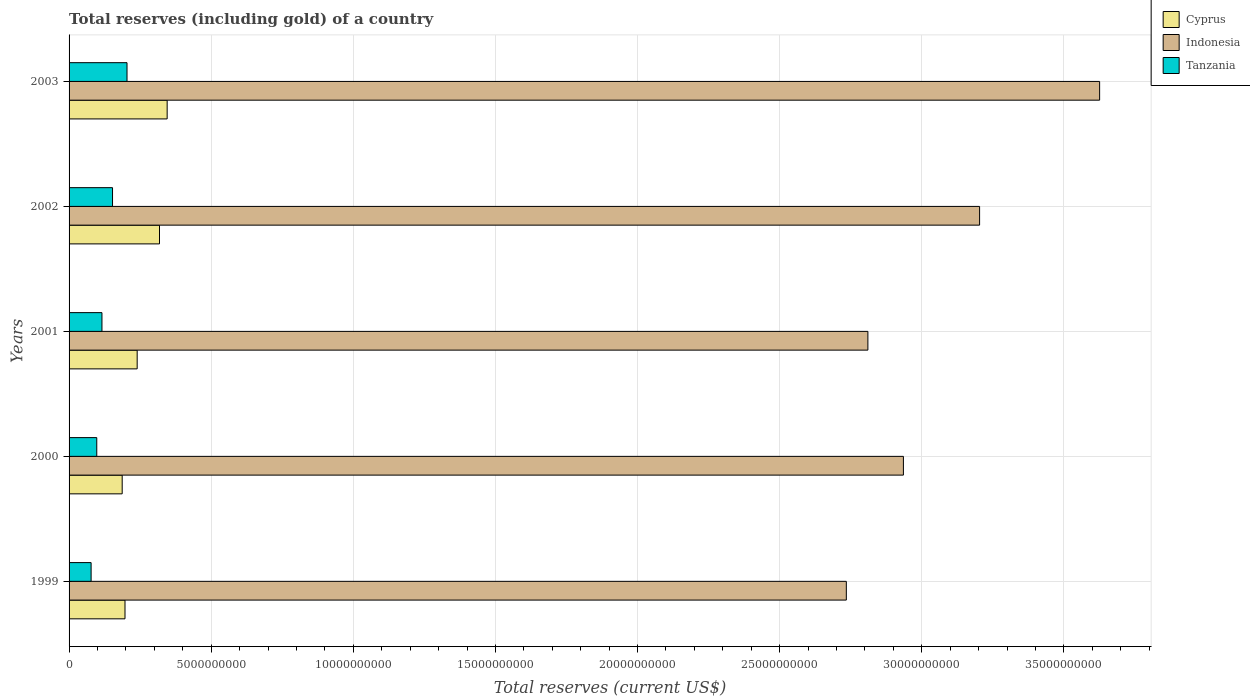Are the number of bars per tick equal to the number of legend labels?
Provide a succinct answer. Yes. Are the number of bars on each tick of the Y-axis equal?
Your answer should be compact. Yes. How many bars are there on the 2nd tick from the top?
Your answer should be compact. 3. How many bars are there on the 2nd tick from the bottom?
Ensure brevity in your answer.  3. What is the label of the 5th group of bars from the top?
Your response must be concise. 1999. In how many cases, is the number of bars for a given year not equal to the number of legend labels?
Offer a terse response. 0. What is the total reserves (including gold) in Cyprus in 2001?
Make the answer very short. 2.40e+09. Across all years, what is the maximum total reserves (including gold) in Indonesia?
Your response must be concise. 3.63e+1. Across all years, what is the minimum total reserves (including gold) in Tanzania?
Your response must be concise. 7.75e+08. In which year was the total reserves (including gold) in Cyprus maximum?
Keep it short and to the point. 2003. In which year was the total reserves (including gold) in Indonesia minimum?
Ensure brevity in your answer.  1999. What is the total total reserves (including gold) in Tanzania in the graph?
Offer a very short reply. 6.47e+09. What is the difference between the total reserves (including gold) in Tanzania in 2000 and that in 2002?
Your response must be concise. -5.55e+08. What is the difference between the total reserves (including gold) in Tanzania in 1999 and the total reserves (including gold) in Cyprus in 2002?
Give a very brief answer. -2.41e+09. What is the average total reserves (including gold) in Cyprus per year?
Offer a very short reply. 2.57e+09. In the year 2002, what is the difference between the total reserves (including gold) in Indonesia and total reserves (including gold) in Tanzania?
Provide a succinct answer. 3.05e+1. What is the ratio of the total reserves (including gold) in Tanzania in 2000 to that in 2002?
Your answer should be compact. 0.64. Is the difference between the total reserves (including gold) in Indonesia in 2001 and 2003 greater than the difference between the total reserves (including gold) in Tanzania in 2001 and 2003?
Provide a succinct answer. No. What is the difference between the highest and the second highest total reserves (including gold) in Indonesia?
Your answer should be compact. 4.22e+09. What is the difference between the highest and the lowest total reserves (including gold) in Tanzania?
Give a very brief answer. 1.26e+09. In how many years, is the total reserves (including gold) in Cyprus greater than the average total reserves (including gold) in Cyprus taken over all years?
Give a very brief answer. 2. What does the 2nd bar from the top in 2003 represents?
Your response must be concise. Indonesia. What does the 1st bar from the bottom in 2000 represents?
Make the answer very short. Cyprus. How many years are there in the graph?
Provide a short and direct response. 5. What is the difference between two consecutive major ticks on the X-axis?
Your answer should be very brief. 5.00e+09. Are the values on the major ticks of X-axis written in scientific E-notation?
Ensure brevity in your answer.  No. Does the graph contain grids?
Give a very brief answer. Yes. Where does the legend appear in the graph?
Your answer should be very brief. Top right. What is the title of the graph?
Provide a succinct answer. Total reserves (including gold) of a country. What is the label or title of the X-axis?
Ensure brevity in your answer.  Total reserves (current US$). What is the label or title of the Y-axis?
Your response must be concise. Years. What is the Total reserves (current US$) in Cyprus in 1999?
Offer a terse response. 1.97e+09. What is the Total reserves (current US$) of Indonesia in 1999?
Give a very brief answer. 2.73e+1. What is the Total reserves (current US$) in Tanzania in 1999?
Your answer should be compact. 7.75e+08. What is the Total reserves (current US$) in Cyprus in 2000?
Your answer should be very brief. 1.87e+09. What is the Total reserves (current US$) in Indonesia in 2000?
Your response must be concise. 2.94e+1. What is the Total reserves (current US$) in Tanzania in 2000?
Provide a short and direct response. 9.74e+08. What is the Total reserves (current US$) of Cyprus in 2001?
Offer a terse response. 2.40e+09. What is the Total reserves (current US$) in Indonesia in 2001?
Keep it short and to the point. 2.81e+1. What is the Total reserves (current US$) of Tanzania in 2001?
Your response must be concise. 1.16e+09. What is the Total reserves (current US$) in Cyprus in 2002?
Your response must be concise. 3.18e+09. What is the Total reserves (current US$) of Indonesia in 2002?
Offer a terse response. 3.20e+1. What is the Total reserves (current US$) in Tanzania in 2002?
Make the answer very short. 1.53e+09. What is the Total reserves (current US$) in Cyprus in 2003?
Offer a terse response. 3.45e+09. What is the Total reserves (current US$) of Indonesia in 2003?
Give a very brief answer. 3.63e+1. What is the Total reserves (current US$) of Tanzania in 2003?
Offer a terse response. 2.04e+09. Across all years, what is the maximum Total reserves (current US$) in Cyprus?
Your answer should be very brief. 3.45e+09. Across all years, what is the maximum Total reserves (current US$) in Indonesia?
Provide a short and direct response. 3.63e+1. Across all years, what is the maximum Total reserves (current US$) in Tanzania?
Keep it short and to the point. 2.04e+09. Across all years, what is the minimum Total reserves (current US$) in Cyprus?
Make the answer very short. 1.87e+09. Across all years, what is the minimum Total reserves (current US$) of Indonesia?
Your answer should be very brief. 2.73e+1. Across all years, what is the minimum Total reserves (current US$) of Tanzania?
Provide a short and direct response. 7.75e+08. What is the total Total reserves (current US$) of Cyprus in the graph?
Your answer should be compact. 1.29e+1. What is the total Total reserves (current US$) of Indonesia in the graph?
Give a very brief answer. 1.53e+11. What is the total Total reserves (current US$) of Tanzania in the graph?
Your response must be concise. 6.47e+09. What is the difference between the Total reserves (current US$) of Cyprus in 1999 and that in 2000?
Give a very brief answer. 9.89e+07. What is the difference between the Total reserves (current US$) of Indonesia in 1999 and that in 2000?
Offer a very short reply. -2.01e+09. What is the difference between the Total reserves (current US$) in Tanzania in 1999 and that in 2000?
Make the answer very short. -1.99e+08. What is the difference between the Total reserves (current US$) in Cyprus in 1999 and that in 2001?
Offer a terse response. -4.29e+08. What is the difference between the Total reserves (current US$) in Indonesia in 1999 and that in 2001?
Offer a terse response. -7.59e+08. What is the difference between the Total reserves (current US$) of Tanzania in 1999 and that in 2001?
Keep it short and to the point. -3.81e+08. What is the difference between the Total reserves (current US$) of Cyprus in 1999 and that in 2002?
Ensure brevity in your answer.  -1.21e+09. What is the difference between the Total reserves (current US$) of Indonesia in 1999 and that in 2002?
Your answer should be very brief. -4.69e+09. What is the difference between the Total reserves (current US$) in Tanzania in 1999 and that in 2002?
Your response must be concise. -7.53e+08. What is the difference between the Total reserves (current US$) in Cyprus in 1999 and that in 2003?
Offer a terse response. -1.48e+09. What is the difference between the Total reserves (current US$) in Indonesia in 1999 and that in 2003?
Provide a succinct answer. -8.91e+09. What is the difference between the Total reserves (current US$) in Tanzania in 1999 and that in 2003?
Make the answer very short. -1.26e+09. What is the difference between the Total reserves (current US$) in Cyprus in 2000 and that in 2001?
Offer a terse response. -5.28e+08. What is the difference between the Total reserves (current US$) of Indonesia in 2000 and that in 2001?
Offer a terse response. 1.25e+09. What is the difference between the Total reserves (current US$) of Tanzania in 2000 and that in 2001?
Your answer should be very brief. -1.82e+08. What is the difference between the Total reserves (current US$) of Cyprus in 2000 and that in 2002?
Your answer should be compact. -1.31e+09. What is the difference between the Total reserves (current US$) in Indonesia in 2000 and that in 2002?
Make the answer very short. -2.68e+09. What is the difference between the Total reserves (current US$) of Tanzania in 2000 and that in 2002?
Keep it short and to the point. -5.55e+08. What is the difference between the Total reserves (current US$) in Cyprus in 2000 and that in 2003?
Offer a very short reply. -1.58e+09. What is the difference between the Total reserves (current US$) in Indonesia in 2000 and that in 2003?
Make the answer very short. -6.90e+09. What is the difference between the Total reserves (current US$) of Tanzania in 2000 and that in 2003?
Provide a succinct answer. -1.06e+09. What is the difference between the Total reserves (current US$) of Cyprus in 2001 and that in 2002?
Your answer should be compact. -7.85e+08. What is the difference between the Total reserves (current US$) in Indonesia in 2001 and that in 2002?
Ensure brevity in your answer.  -3.93e+09. What is the difference between the Total reserves (current US$) of Tanzania in 2001 and that in 2002?
Offer a terse response. -3.72e+08. What is the difference between the Total reserves (current US$) of Cyprus in 2001 and that in 2003?
Keep it short and to the point. -1.05e+09. What is the difference between the Total reserves (current US$) in Indonesia in 2001 and that in 2003?
Keep it short and to the point. -8.15e+09. What is the difference between the Total reserves (current US$) of Tanzania in 2001 and that in 2003?
Provide a short and direct response. -8.82e+08. What is the difference between the Total reserves (current US$) in Cyprus in 2002 and that in 2003?
Provide a short and direct response. -2.70e+08. What is the difference between the Total reserves (current US$) of Indonesia in 2002 and that in 2003?
Offer a terse response. -4.22e+09. What is the difference between the Total reserves (current US$) of Tanzania in 2002 and that in 2003?
Your answer should be very brief. -5.10e+08. What is the difference between the Total reserves (current US$) in Cyprus in 1999 and the Total reserves (current US$) in Indonesia in 2000?
Give a very brief answer. -2.74e+1. What is the difference between the Total reserves (current US$) in Cyprus in 1999 and the Total reserves (current US$) in Tanzania in 2000?
Keep it short and to the point. 9.93e+08. What is the difference between the Total reserves (current US$) of Indonesia in 1999 and the Total reserves (current US$) of Tanzania in 2000?
Keep it short and to the point. 2.64e+1. What is the difference between the Total reserves (current US$) of Cyprus in 1999 and the Total reserves (current US$) of Indonesia in 2001?
Offer a terse response. -2.61e+1. What is the difference between the Total reserves (current US$) of Cyprus in 1999 and the Total reserves (current US$) of Tanzania in 2001?
Your response must be concise. 8.11e+08. What is the difference between the Total reserves (current US$) in Indonesia in 1999 and the Total reserves (current US$) in Tanzania in 2001?
Make the answer very short. 2.62e+1. What is the difference between the Total reserves (current US$) of Cyprus in 1999 and the Total reserves (current US$) of Indonesia in 2002?
Your answer should be very brief. -3.01e+1. What is the difference between the Total reserves (current US$) in Cyprus in 1999 and the Total reserves (current US$) in Tanzania in 2002?
Offer a terse response. 4.39e+08. What is the difference between the Total reserves (current US$) of Indonesia in 1999 and the Total reserves (current US$) of Tanzania in 2002?
Your response must be concise. 2.58e+1. What is the difference between the Total reserves (current US$) in Cyprus in 1999 and the Total reserves (current US$) in Indonesia in 2003?
Ensure brevity in your answer.  -3.43e+1. What is the difference between the Total reserves (current US$) in Cyprus in 1999 and the Total reserves (current US$) in Tanzania in 2003?
Provide a short and direct response. -7.10e+07. What is the difference between the Total reserves (current US$) in Indonesia in 1999 and the Total reserves (current US$) in Tanzania in 2003?
Give a very brief answer. 2.53e+1. What is the difference between the Total reserves (current US$) in Cyprus in 2000 and the Total reserves (current US$) in Indonesia in 2001?
Ensure brevity in your answer.  -2.62e+1. What is the difference between the Total reserves (current US$) in Cyprus in 2000 and the Total reserves (current US$) in Tanzania in 2001?
Offer a terse response. 7.12e+08. What is the difference between the Total reserves (current US$) of Indonesia in 2000 and the Total reserves (current US$) of Tanzania in 2001?
Give a very brief answer. 2.82e+1. What is the difference between the Total reserves (current US$) in Cyprus in 2000 and the Total reserves (current US$) in Indonesia in 2002?
Your response must be concise. -3.02e+1. What is the difference between the Total reserves (current US$) in Cyprus in 2000 and the Total reserves (current US$) in Tanzania in 2002?
Your response must be concise. 3.40e+08. What is the difference between the Total reserves (current US$) of Indonesia in 2000 and the Total reserves (current US$) of Tanzania in 2002?
Offer a terse response. 2.78e+1. What is the difference between the Total reserves (current US$) in Cyprus in 2000 and the Total reserves (current US$) in Indonesia in 2003?
Your response must be concise. -3.44e+1. What is the difference between the Total reserves (current US$) of Cyprus in 2000 and the Total reserves (current US$) of Tanzania in 2003?
Make the answer very short. -1.70e+08. What is the difference between the Total reserves (current US$) in Indonesia in 2000 and the Total reserves (current US$) in Tanzania in 2003?
Ensure brevity in your answer.  2.73e+1. What is the difference between the Total reserves (current US$) of Cyprus in 2001 and the Total reserves (current US$) of Indonesia in 2002?
Provide a succinct answer. -2.96e+1. What is the difference between the Total reserves (current US$) in Cyprus in 2001 and the Total reserves (current US$) in Tanzania in 2002?
Give a very brief answer. 8.67e+08. What is the difference between the Total reserves (current US$) in Indonesia in 2001 and the Total reserves (current US$) in Tanzania in 2002?
Offer a terse response. 2.66e+1. What is the difference between the Total reserves (current US$) of Cyprus in 2001 and the Total reserves (current US$) of Indonesia in 2003?
Your response must be concise. -3.39e+1. What is the difference between the Total reserves (current US$) in Cyprus in 2001 and the Total reserves (current US$) in Tanzania in 2003?
Ensure brevity in your answer.  3.58e+08. What is the difference between the Total reserves (current US$) in Indonesia in 2001 and the Total reserves (current US$) in Tanzania in 2003?
Ensure brevity in your answer.  2.61e+1. What is the difference between the Total reserves (current US$) in Cyprus in 2002 and the Total reserves (current US$) in Indonesia in 2003?
Give a very brief answer. -3.31e+1. What is the difference between the Total reserves (current US$) of Cyprus in 2002 and the Total reserves (current US$) of Tanzania in 2003?
Your answer should be compact. 1.14e+09. What is the difference between the Total reserves (current US$) in Indonesia in 2002 and the Total reserves (current US$) in Tanzania in 2003?
Ensure brevity in your answer.  3.00e+1. What is the average Total reserves (current US$) in Cyprus per year?
Offer a terse response. 2.57e+09. What is the average Total reserves (current US$) of Indonesia per year?
Ensure brevity in your answer.  3.06e+1. What is the average Total reserves (current US$) of Tanzania per year?
Your answer should be compact. 1.29e+09. In the year 1999, what is the difference between the Total reserves (current US$) of Cyprus and Total reserves (current US$) of Indonesia?
Offer a terse response. -2.54e+1. In the year 1999, what is the difference between the Total reserves (current US$) of Cyprus and Total reserves (current US$) of Tanzania?
Offer a terse response. 1.19e+09. In the year 1999, what is the difference between the Total reserves (current US$) in Indonesia and Total reserves (current US$) in Tanzania?
Offer a very short reply. 2.66e+1. In the year 2000, what is the difference between the Total reserves (current US$) in Cyprus and Total reserves (current US$) in Indonesia?
Offer a very short reply. -2.75e+1. In the year 2000, what is the difference between the Total reserves (current US$) of Cyprus and Total reserves (current US$) of Tanzania?
Offer a terse response. 8.94e+08. In the year 2000, what is the difference between the Total reserves (current US$) in Indonesia and Total reserves (current US$) in Tanzania?
Your answer should be compact. 2.84e+1. In the year 2001, what is the difference between the Total reserves (current US$) of Cyprus and Total reserves (current US$) of Indonesia?
Your response must be concise. -2.57e+1. In the year 2001, what is the difference between the Total reserves (current US$) of Cyprus and Total reserves (current US$) of Tanzania?
Offer a very short reply. 1.24e+09. In the year 2001, what is the difference between the Total reserves (current US$) in Indonesia and Total reserves (current US$) in Tanzania?
Give a very brief answer. 2.69e+1. In the year 2002, what is the difference between the Total reserves (current US$) of Cyprus and Total reserves (current US$) of Indonesia?
Offer a very short reply. -2.89e+1. In the year 2002, what is the difference between the Total reserves (current US$) in Cyprus and Total reserves (current US$) in Tanzania?
Your answer should be very brief. 1.65e+09. In the year 2002, what is the difference between the Total reserves (current US$) in Indonesia and Total reserves (current US$) in Tanzania?
Your answer should be very brief. 3.05e+1. In the year 2003, what is the difference between the Total reserves (current US$) in Cyprus and Total reserves (current US$) in Indonesia?
Your response must be concise. -3.28e+1. In the year 2003, what is the difference between the Total reserves (current US$) in Cyprus and Total reserves (current US$) in Tanzania?
Your answer should be very brief. 1.41e+09. In the year 2003, what is the difference between the Total reserves (current US$) in Indonesia and Total reserves (current US$) in Tanzania?
Offer a very short reply. 3.42e+1. What is the ratio of the Total reserves (current US$) in Cyprus in 1999 to that in 2000?
Give a very brief answer. 1.05. What is the ratio of the Total reserves (current US$) of Indonesia in 1999 to that in 2000?
Provide a succinct answer. 0.93. What is the ratio of the Total reserves (current US$) of Tanzania in 1999 to that in 2000?
Keep it short and to the point. 0.8. What is the ratio of the Total reserves (current US$) of Cyprus in 1999 to that in 2001?
Provide a succinct answer. 0.82. What is the ratio of the Total reserves (current US$) in Indonesia in 1999 to that in 2001?
Your answer should be very brief. 0.97. What is the ratio of the Total reserves (current US$) of Tanzania in 1999 to that in 2001?
Keep it short and to the point. 0.67. What is the ratio of the Total reserves (current US$) in Cyprus in 1999 to that in 2002?
Your answer should be compact. 0.62. What is the ratio of the Total reserves (current US$) in Indonesia in 1999 to that in 2002?
Offer a very short reply. 0.85. What is the ratio of the Total reserves (current US$) of Tanzania in 1999 to that in 2002?
Your answer should be compact. 0.51. What is the ratio of the Total reserves (current US$) in Cyprus in 1999 to that in 2003?
Your response must be concise. 0.57. What is the ratio of the Total reserves (current US$) of Indonesia in 1999 to that in 2003?
Keep it short and to the point. 0.75. What is the ratio of the Total reserves (current US$) in Tanzania in 1999 to that in 2003?
Provide a succinct answer. 0.38. What is the ratio of the Total reserves (current US$) of Cyprus in 2000 to that in 2001?
Give a very brief answer. 0.78. What is the ratio of the Total reserves (current US$) of Indonesia in 2000 to that in 2001?
Your answer should be compact. 1.04. What is the ratio of the Total reserves (current US$) in Tanzania in 2000 to that in 2001?
Provide a succinct answer. 0.84. What is the ratio of the Total reserves (current US$) of Cyprus in 2000 to that in 2002?
Your answer should be compact. 0.59. What is the ratio of the Total reserves (current US$) in Indonesia in 2000 to that in 2002?
Provide a succinct answer. 0.92. What is the ratio of the Total reserves (current US$) in Tanzania in 2000 to that in 2002?
Your response must be concise. 0.64. What is the ratio of the Total reserves (current US$) in Cyprus in 2000 to that in 2003?
Give a very brief answer. 0.54. What is the ratio of the Total reserves (current US$) of Indonesia in 2000 to that in 2003?
Offer a terse response. 0.81. What is the ratio of the Total reserves (current US$) in Tanzania in 2000 to that in 2003?
Your answer should be very brief. 0.48. What is the ratio of the Total reserves (current US$) of Cyprus in 2001 to that in 2002?
Ensure brevity in your answer.  0.75. What is the ratio of the Total reserves (current US$) of Indonesia in 2001 to that in 2002?
Offer a very short reply. 0.88. What is the ratio of the Total reserves (current US$) of Tanzania in 2001 to that in 2002?
Your response must be concise. 0.76. What is the ratio of the Total reserves (current US$) in Cyprus in 2001 to that in 2003?
Your answer should be compact. 0.69. What is the ratio of the Total reserves (current US$) in Indonesia in 2001 to that in 2003?
Give a very brief answer. 0.78. What is the ratio of the Total reserves (current US$) in Tanzania in 2001 to that in 2003?
Ensure brevity in your answer.  0.57. What is the ratio of the Total reserves (current US$) of Cyprus in 2002 to that in 2003?
Your response must be concise. 0.92. What is the ratio of the Total reserves (current US$) in Indonesia in 2002 to that in 2003?
Ensure brevity in your answer.  0.88. What is the difference between the highest and the second highest Total reserves (current US$) in Cyprus?
Provide a short and direct response. 2.70e+08. What is the difference between the highest and the second highest Total reserves (current US$) in Indonesia?
Your answer should be very brief. 4.22e+09. What is the difference between the highest and the second highest Total reserves (current US$) of Tanzania?
Offer a terse response. 5.10e+08. What is the difference between the highest and the lowest Total reserves (current US$) in Cyprus?
Provide a short and direct response. 1.58e+09. What is the difference between the highest and the lowest Total reserves (current US$) of Indonesia?
Make the answer very short. 8.91e+09. What is the difference between the highest and the lowest Total reserves (current US$) in Tanzania?
Your answer should be very brief. 1.26e+09. 